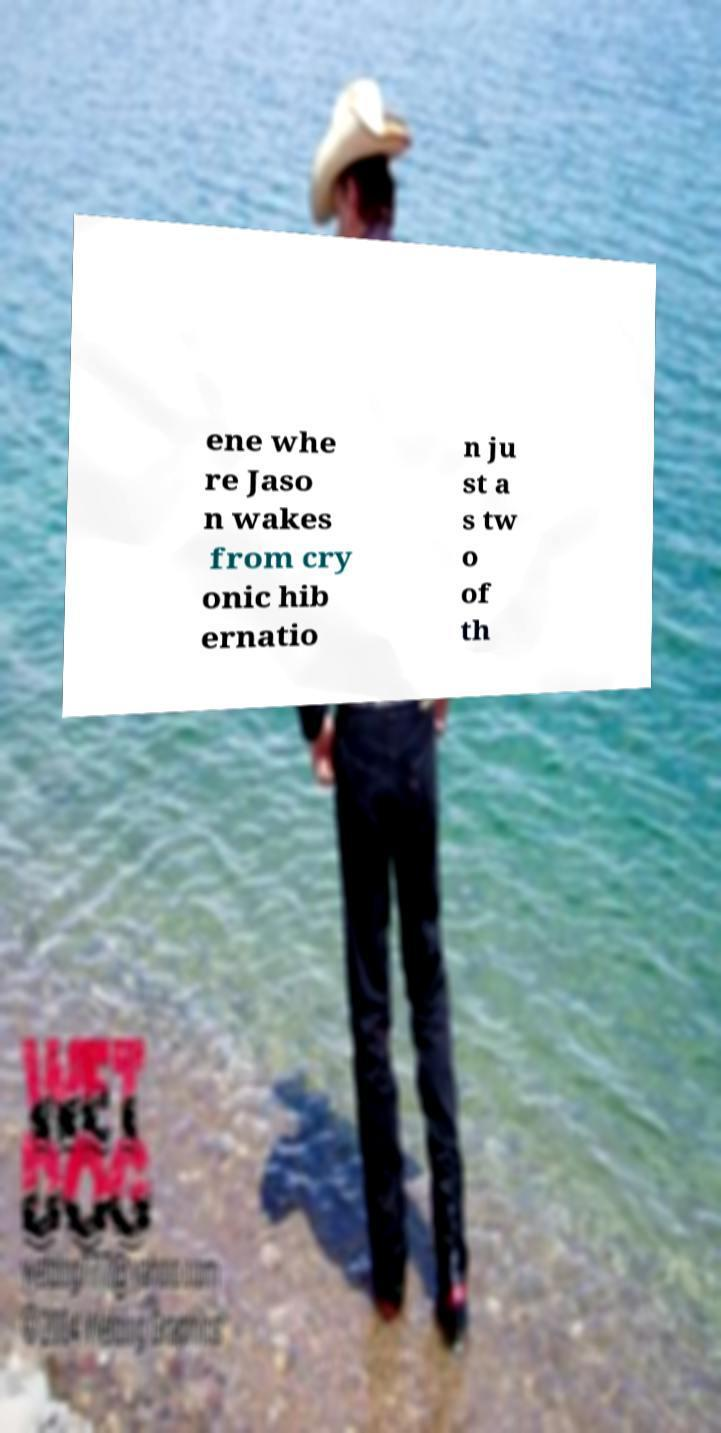I need the written content from this picture converted into text. Can you do that? ene whe re Jaso n wakes from cry onic hib ernatio n ju st a s tw o of th 